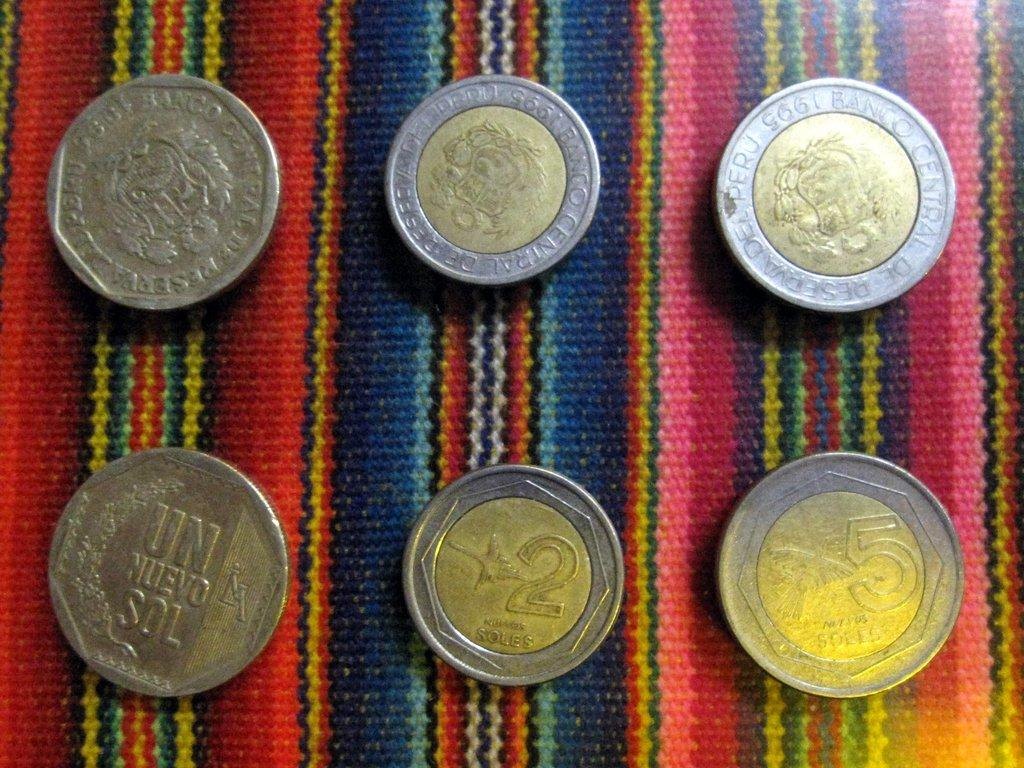<image>
Offer a succinct explanation of the picture presented. A  Peruvian set of six coins such as soles 